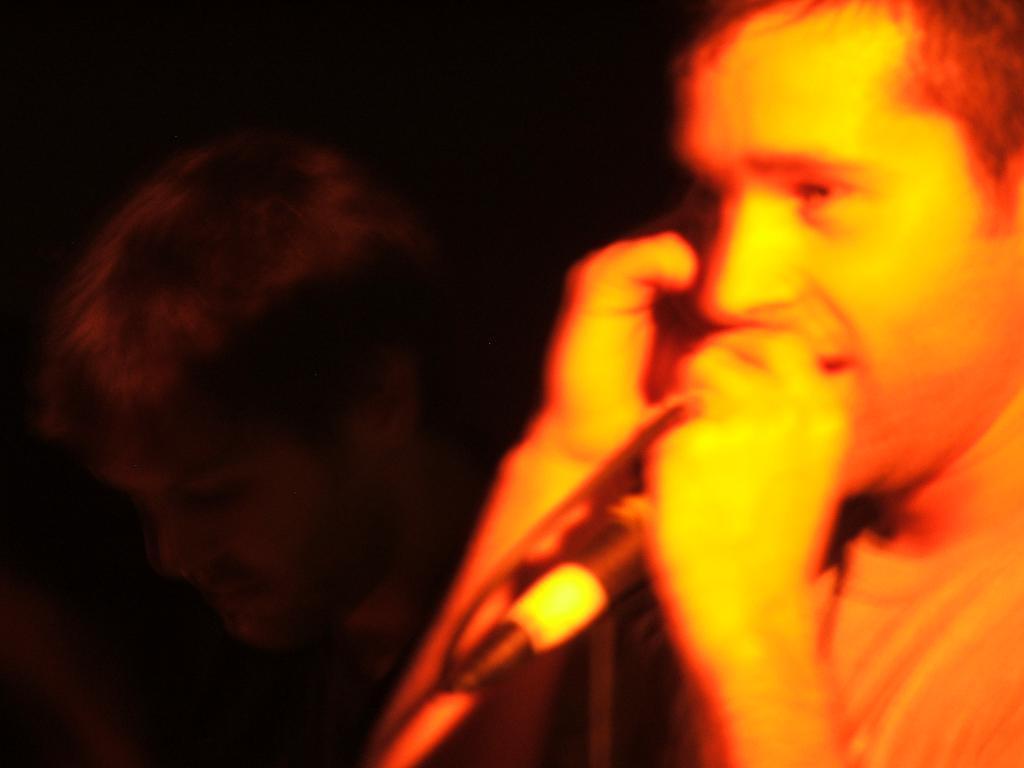Please provide a concise description of this image. Here we can see two persons. He is holding a mike with his hand. There is a dark background. 